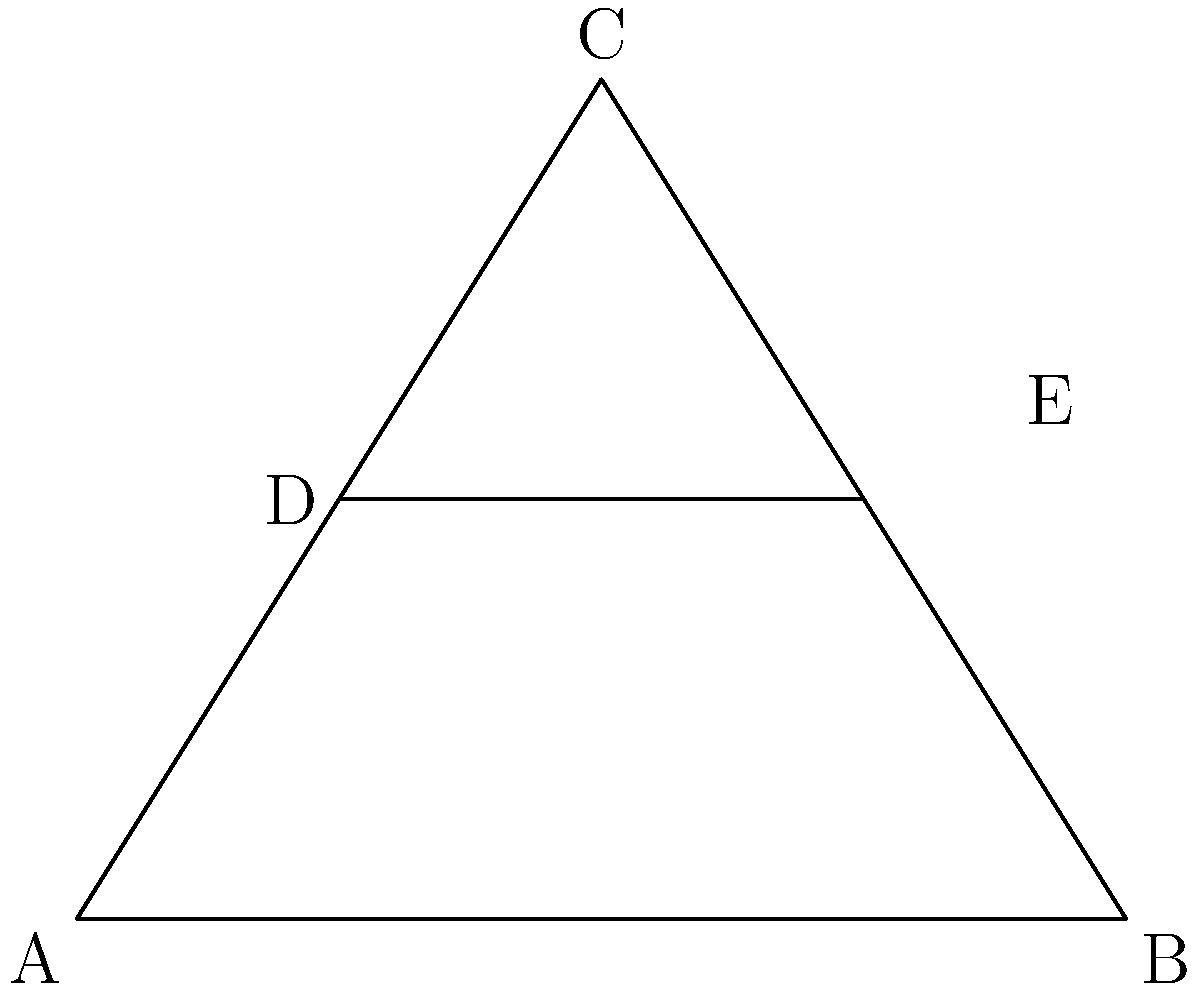In the Gothic cathedral's flying buttress system shown above, triangle ABC represents the main structure, with DE as a horizontal support beam. If the angle at both A and B is 30°, and DE bisects AC and BC, what is the ratio of DE to AB? Let's approach this step-by-step:

1) In an isosceles triangle, the altitude to the base bisects the base. Here, both AD and BE are altitudes to the base AB, as they form right angles with AC and BC respectively.

2) Since DE bisects both AC and BC, it must be parallel to AB and located halfway up the height of the triangle.

3) In a 30-60-90 triangle, the ratio of the shorter leg (half of AB) to the height (AD or BE) is 1:$\sqrt{3}$.

4) Let's say AB = 2x. Then the height of the triangle (AD or BE) = $x\sqrt{3}$.

5) DE is located halfway up this height, so its distance from AB is $\frac{x\sqrt{3}}{2}$.

6) In similar triangles, the ratio of corresponding sides is constant. The ratio of the distance of DE from AB to the full height is 1:2, so the ratio of DE to AB must also be 1:2.

7) Therefore, DE = x (half of AB).

8) The ratio of DE to AB is thus x : 2x, which simplifies to 1:2.
Answer: 1:2 